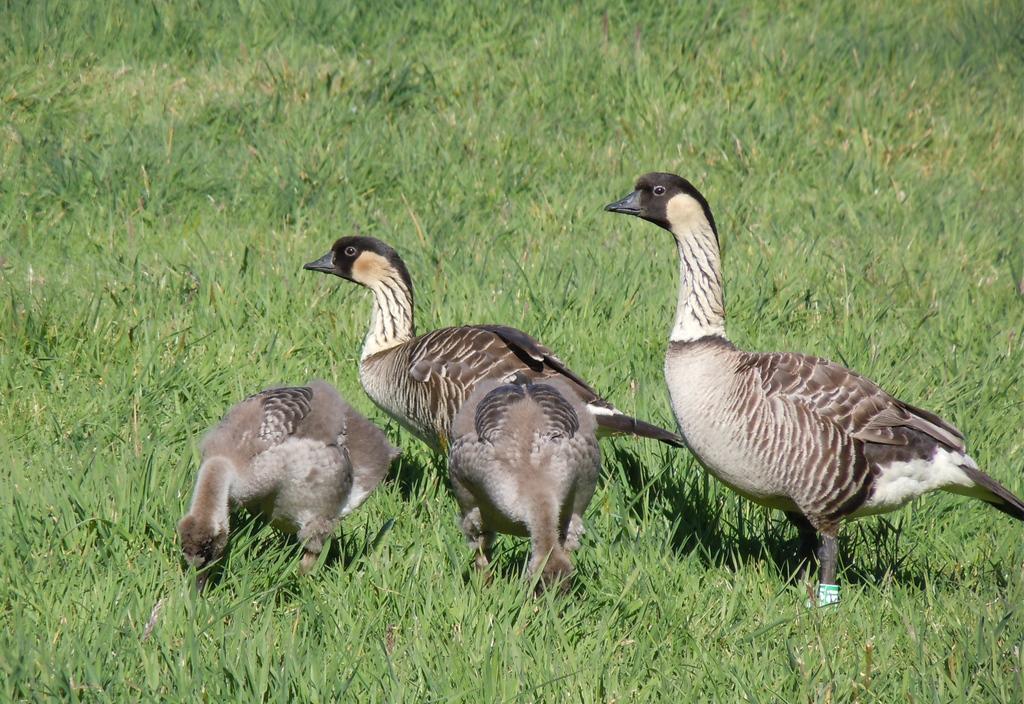In one or two sentences, can you explain what this image depicts? In this picture we can see few birds on the grass. 